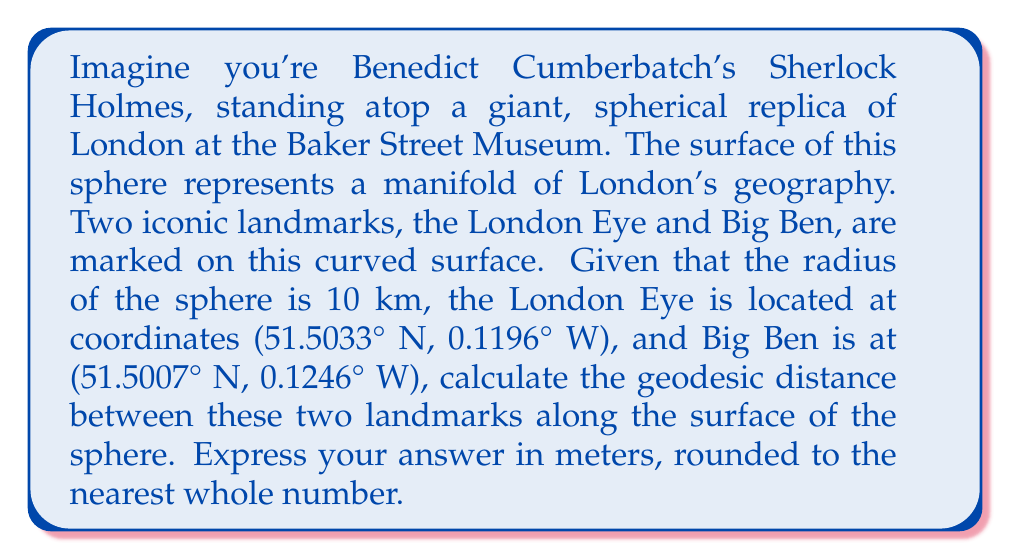Teach me how to tackle this problem. To solve this problem, we'll use the Haversine formula, which calculates the great-circle distance between two points on a sphere given their latitudes and longitudes. This is perfect for our Sherlock-worthy deduction on our London sphere!

Step 1: Convert the coordinates from degrees to radians.
London Eye: $\phi_1 = 51.5033° \times \frac{\pi}{180} = 0.8988$ rad, $\lambda_1 = -0.1196° \times \frac{\pi}{180} = -0.00209$ rad
Big Ben: $\phi_2 = 51.5007° \times \frac{\pi}{180} = 0.8987$ rad, $\lambda_2 = -0.1246° \times \frac{\pi}{180} = -0.00217$ rad

Step 2: Calculate the differences in latitude and longitude.
$\Delta\phi = \phi_2 - \phi_1 = -0.0001$ rad
$\Delta\lambda = \lambda_2 - \lambda_1 = -0.00008$ rad

Step 3: Apply the Haversine formula:
$$a = \sin^2(\frac{\Delta\phi}{2}) + \cos(\phi_1) \cos(\phi_2) \sin^2(\frac{\Delta\lambda}{2})$$
$$c = 2 \times \arctan2(\sqrt{a}, \sqrt{1-a})$$
$$d = R \times c$$

Where $R$ is the radius of the sphere (10 km = 10,000 m).

Step 4: Calculate the intermediate values:
$$a = \sin^2(-0.00005) + \cos(0.8988) \cos(0.8987) \sin^2(-0.00004) = 1.6534 \times 10^{-8}$$
$$c = 2 \times \arctan2(\sqrt{1.6534 \times 10^{-8}}, \sqrt{1 - 1.6534 \times 10^{-8}}) = 0.0001285$$

Step 5: Calculate the final distance:
$$d = 10000 \times 0.0001285 = 1.285$$ meters

Step 6: Round to the nearest whole number:
1.285 meters rounds to 1 meter.
Answer: 1 meter 